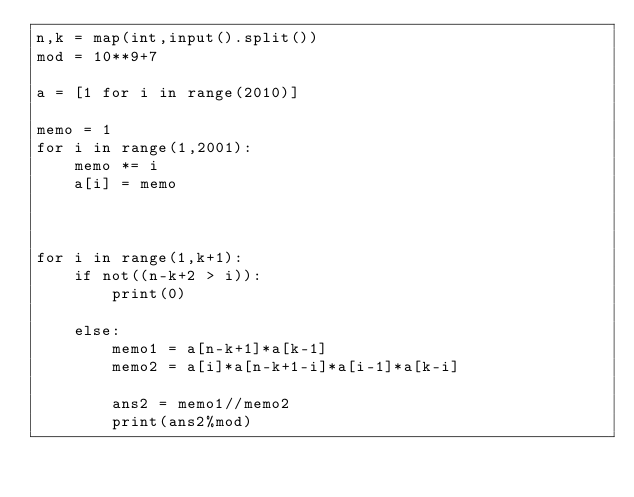<code> <loc_0><loc_0><loc_500><loc_500><_Python_>n,k = map(int,input().split())
mod = 10**9+7

a = [1 for i in range(2010)]

memo = 1
for i in range(1,2001):
    memo *= i
    a[i] = memo



for i in range(1,k+1):
    if not((n-k+2 > i)):
        print(0)

    else:
        memo1 = a[n-k+1]*a[k-1]
        memo2 = a[i]*a[n-k+1-i]*a[i-1]*a[k-i]

        ans2 = memo1//memo2
        print(ans2%mod)
    
</code> 